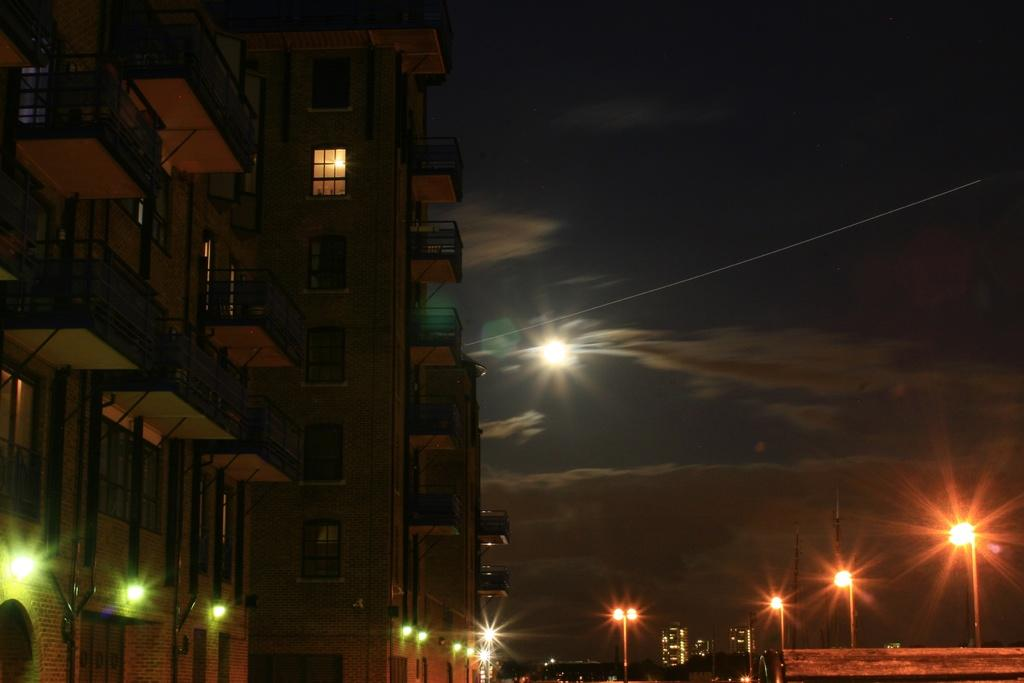What time of day is depicted in the image? The image depicts a night view. What type of structure is visible in the image? There is a building with many windows in the image. Does the building have any additional features? Yes, the building has balconies. What can be seen on the right side of the image? There are street light poles on the right side of the image. How many cakes are visible on the balconies in the image? There are no cakes visible on the balconies in the image. Can you tell me the total cost of the items in the image based on the receipt? There is no receipt present in the image. 